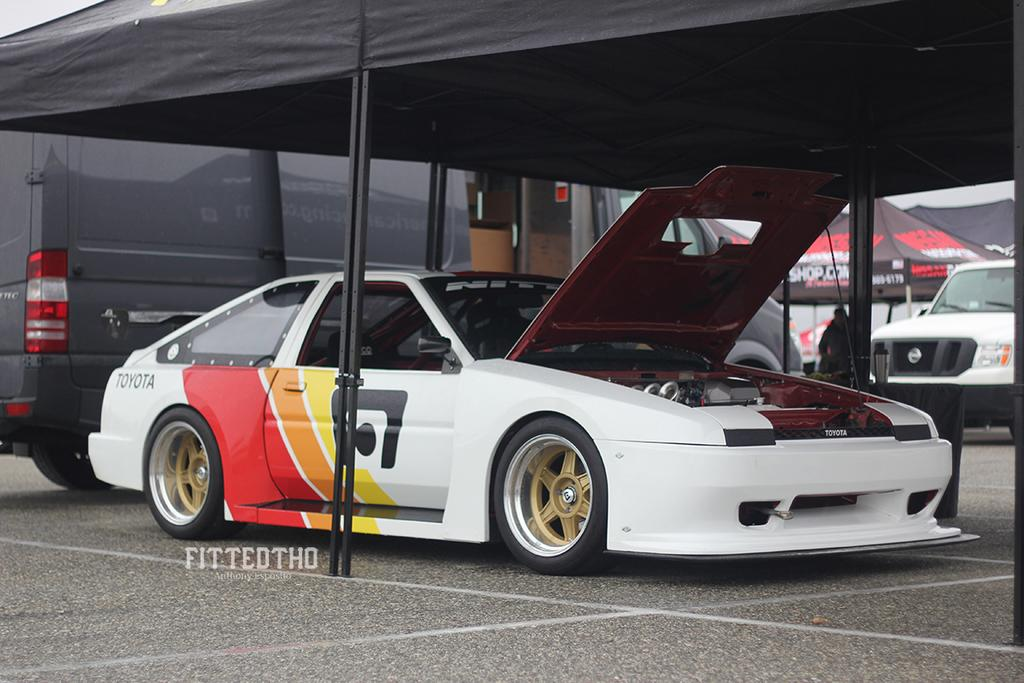What types of vehicles are on the ground in the image? The specific types of vehicles are not mentioned, but there are vehicles on the ground in the image. What kind of temporary shelters can be seen in the image? There are tents in the image. Can you describe the person in the image? There is a person in the image, but their appearance or actions are not specified. What other objects are present in the image? There are some unspecified objects in the image. How far away is the waste disposal site from the person in the image? There is no mention of a waste disposal site in the image, so it is not possible to determine the distance between the person and such a site. 